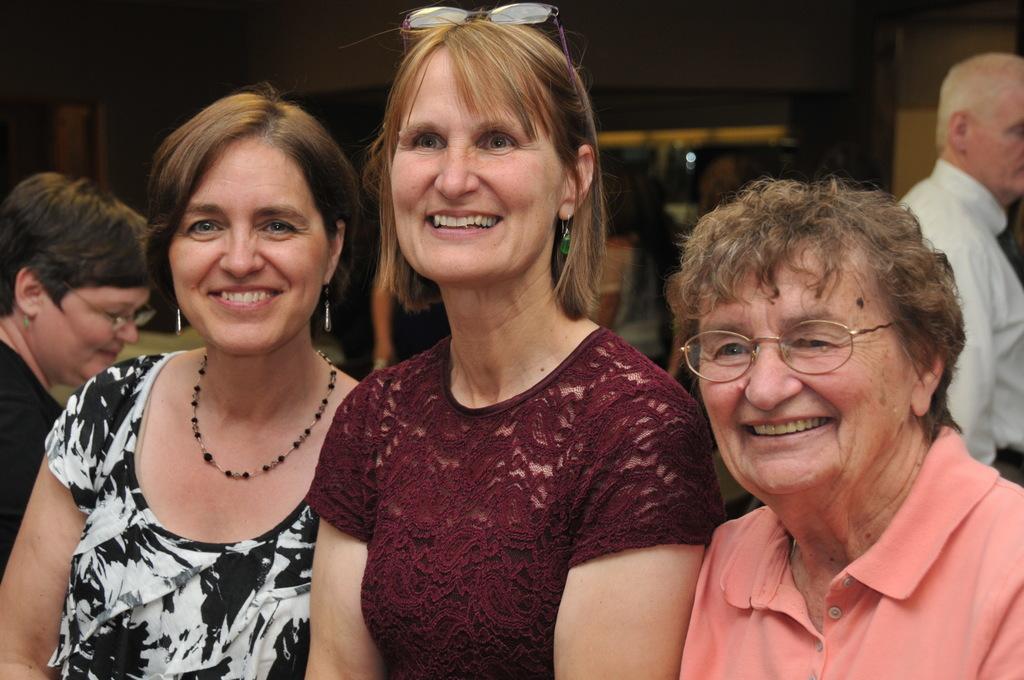Please provide a concise description of this image. In this image we can see women. In the background we can see persons, door and wall. 